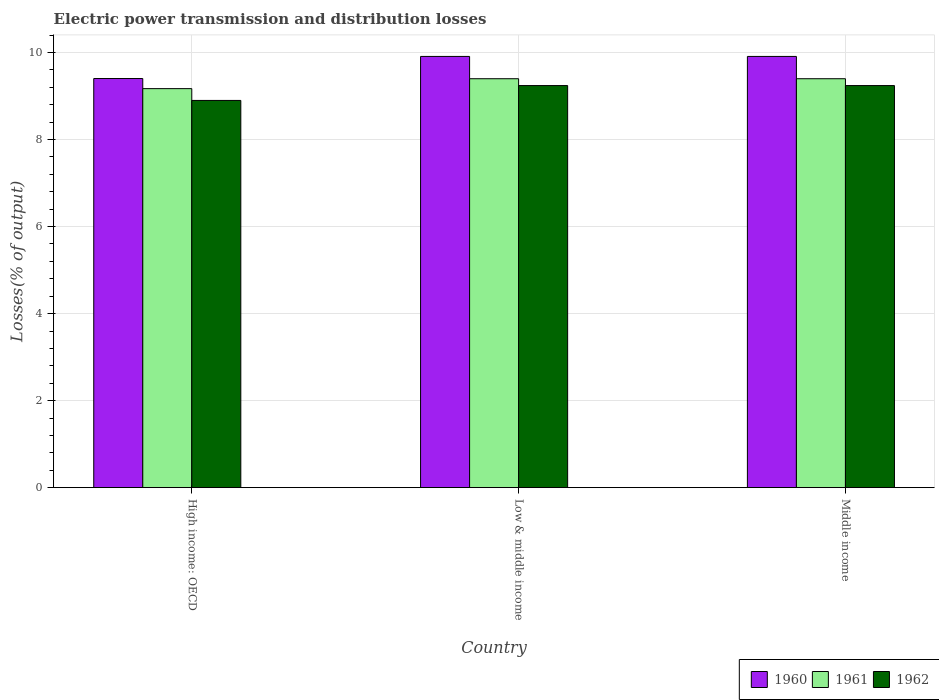How many different coloured bars are there?
Your response must be concise. 3. How many groups of bars are there?
Give a very brief answer. 3. Are the number of bars per tick equal to the number of legend labels?
Offer a terse response. Yes. Are the number of bars on each tick of the X-axis equal?
Offer a terse response. Yes. In how many cases, is the number of bars for a given country not equal to the number of legend labels?
Ensure brevity in your answer.  0. What is the electric power transmission and distribution losses in 1960 in Low & middle income?
Give a very brief answer. 9.91. Across all countries, what is the maximum electric power transmission and distribution losses in 1960?
Keep it short and to the point. 9.91. Across all countries, what is the minimum electric power transmission and distribution losses in 1961?
Make the answer very short. 9.17. In which country was the electric power transmission and distribution losses in 1960 minimum?
Your answer should be very brief. High income: OECD. What is the total electric power transmission and distribution losses in 1960 in the graph?
Provide a succinct answer. 29.23. What is the difference between the electric power transmission and distribution losses in 1961 in Low & middle income and that in Middle income?
Provide a short and direct response. 0. What is the difference between the electric power transmission and distribution losses in 1962 in Low & middle income and the electric power transmission and distribution losses in 1960 in Middle income?
Give a very brief answer. -0.67. What is the average electric power transmission and distribution losses in 1960 per country?
Keep it short and to the point. 9.74. What is the difference between the electric power transmission and distribution losses of/in 1962 and electric power transmission and distribution losses of/in 1960 in High income: OECD?
Your response must be concise. -0.5. What is the ratio of the electric power transmission and distribution losses in 1961 in High income: OECD to that in Low & middle income?
Your answer should be very brief. 0.98. Is the difference between the electric power transmission and distribution losses in 1962 in High income: OECD and Low & middle income greater than the difference between the electric power transmission and distribution losses in 1960 in High income: OECD and Low & middle income?
Provide a succinct answer. Yes. What is the difference between the highest and the second highest electric power transmission and distribution losses in 1960?
Give a very brief answer. 0.51. What is the difference between the highest and the lowest electric power transmission and distribution losses in 1962?
Your response must be concise. 0.34. What does the 1st bar from the left in High income: OECD represents?
Your answer should be compact. 1960. Is it the case that in every country, the sum of the electric power transmission and distribution losses in 1960 and electric power transmission and distribution losses in 1961 is greater than the electric power transmission and distribution losses in 1962?
Ensure brevity in your answer.  Yes. How many bars are there?
Your answer should be compact. 9. Are all the bars in the graph horizontal?
Make the answer very short. No. What is the difference between two consecutive major ticks on the Y-axis?
Your answer should be compact. 2. Does the graph contain grids?
Provide a succinct answer. Yes. Where does the legend appear in the graph?
Keep it short and to the point. Bottom right. How are the legend labels stacked?
Your response must be concise. Horizontal. What is the title of the graph?
Give a very brief answer. Electric power transmission and distribution losses. Does "1971" appear as one of the legend labels in the graph?
Give a very brief answer. No. What is the label or title of the Y-axis?
Make the answer very short. Losses(% of output). What is the Losses(% of output) in 1960 in High income: OECD?
Make the answer very short. 9.4. What is the Losses(% of output) of 1961 in High income: OECD?
Give a very brief answer. 9.17. What is the Losses(% of output) in 1962 in High income: OECD?
Ensure brevity in your answer.  8.9. What is the Losses(% of output) in 1960 in Low & middle income?
Make the answer very short. 9.91. What is the Losses(% of output) of 1961 in Low & middle income?
Ensure brevity in your answer.  9.4. What is the Losses(% of output) in 1962 in Low & middle income?
Provide a succinct answer. 9.24. What is the Losses(% of output) in 1960 in Middle income?
Provide a succinct answer. 9.91. What is the Losses(% of output) of 1961 in Middle income?
Provide a succinct answer. 9.4. What is the Losses(% of output) of 1962 in Middle income?
Offer a terse response. 9.24. Across all countries, what is the maximum Losses(% of output) in 1960?
Give a very brief answer. 9.91. Across all countries, what is the maximum Losses(% of output) in 1961?
Your answer should be very brief. 9.4. Across all countries, what is the maximum Losses(% of output) of 1962?
Give a very brief answer. 9.24. Across all countries, what is the minimum Losses(% of output) of 1960?
Your answer should be very brief. 9.4. Across all countries, what is the minimum Losses(% of output) in 1961?
Your response must be concise. 9.17. Across all countries, what is the minimum Losses(% of output) in 1962?
Provide a short and direct response. 8.9. What is the total Losses(% of output) in 1960 in the graph?
Your answer should be compact. 29.23. What is the total Losses(% of output) of 1961 in the graph?
Offer a very short reply. 27.97. What is the total Losses(% of output) of 1962 in the graph?
Provide a short and direct response. 27.38. What is the difference between the Losses(% of output) of 1960 in High income: OECD and that in Low & middle income?
Keep it short and to the point. -0.51. What is the difference between the Losses(% of output) of 1961 in High income: OECD and that in Low & middle income?
Offer a very short reply. -0.23. What is the difference between the Losses(% of output) of 1962 in High income: OECD and that in Low & middle income?
Your answer should be very brief. -0.34. What is the difference between the Losses(% of output) in 1960 in High income: OECD and that in Middle income?
Provide a short and direct response. -0.51. What is the difference between the Losses(% of output) of 1961 in High income: OECD and that in Middle income?
Provide a succinct answer. -0.23. What is the difference between the Losses(% of output) in 1962 in High income: OECD and that in Middle income?
Provide a short and direct response. -0.34. What is the difference between the Losses(% of output) in 1960 in Low & middle income and that in Middle income?
Offer a terse response. 0. What is the difference between the Losses(% of output) of 1961 in Low & middle income and that in Middle income?
Provide a succinct answer. 0. What is the difference between the Losses(% of output) of 1960 in High income: OECD and the Losses(% of output) of 1961 in Low & middle income?
Ensure brevity in your answer.  0. What is the difference between the Losses(% of output) in 1960 in High income: OECD and the Losses(% of output) in 1962 in Low & middle income?
Make the answer very short. 0.16. What is the difference between the Losses(% of output) of 1961 in High income: OECD and the Losses(% of output) of 1962 in Low & middle income?
Your answer should be compact. -0.07. What is the difference between the Losses(% of output) in 1960 in High income: OECD and the Losses(% of output) in 1961 in Middle income?
Provide a short and direct response. 0. What is the difference between the Losses(% of output) in 1960 in High income: OECD and the Losses(% of output) in 1962 in Middle income?
Ensure brevity in your answer.  0.16. What is the difference between the Losses(% of output) of 1961 in High income: OECD and the Losses(% of output) of 1962 in Middle income?
Keep it short and to the point. -0.07. What is the difference between the Losses(% of output) in 1960 in Low & middle income and the Losses(% of output) in 1961 in Middle income?
Provide a succinct answer. 0.51. What is the difference between the Losses(% of output) in 1960 in Low & middle income and the Losses(% of output) in 1962 in Middle income?
Give a very brief answer. 0.67. What is the difference between the Losses(% of output) of 1961 in Low & middle income and the Losses(% of output) of 1962 in Middle income?
Your answer should be very brief. 0.16. What is the average Losses(% of output) of 1960 per country?
Make the answer very short. 9.74. What is the average Losses(% of output) of 1961 per country?
Your response must be concise. 9.32. What is the average Losses(% of output) of 1962 per country?
Offer a very short reply. 9.13. What is the difference between the Losses(% of output) in 1960 and Losses(% of output) in 1961 in High income: OECD?
Keep it short and to the point. 0.23. What is the difference between the Losses(% of output) of 1960 and Losses(% of output) of 1962 in High income: OECD?
Your response must be concise. 0.5. What is the difference between the Losses(% of output) of 1961 and Losses(% of output) of 1962 in High income: OECD?
Your answer should be very brief. 0.27. What is the difference between the Losses(% of output) in 1960 and Losses(% of output) in 1961 in Low & middle income?
Offer a very short reply. 0.51. What is the difference between the Losses(% of output) in 1960 and Losses(% of output) in 1962 in Low & middle income?
Provide a short and direct response. 0.67. What is the difference between the Losses(% of output) in 1961 and Losses(% of output) in 1962 in Low & middle income?
Keep it short and to the point. 0.16. What is the difference between the Losses(% of output) of 1960 and Losses(% of output) of 1961 in Middle income?
Offer a terse response. 0.51. What is the difference between the Losses(% of output) of 1960 and Losses(% of output) of 1962 in Middle income?
Make the answer very short. 0.67. What is the difference between the Losses(% of output) in 1961 and Losses(% of output) in 1962 in Middle income?
Ensure brevity in your answer.  0.16. What is the ratio of the Losses(% of output) of 1960 in High income: OECD to that in Low & middle income?
Provide a short and direct response. 0.95. What is the ratio of the Losses(% of output) in 1961 in High income: OECD to that in Low & middle income?
Offer a very short reply. 0.98. What is the ratio of the Losses(% of output) in 1960 in High income: OECD to that in Middle income?
Your response must be concise. 0.95. What is the ratio of the Losses(% of output) in 1961 in High income: OECD to that in Middle income?
Keep it short and to the point. 0.98. What is the ratio of the Losses(% of output) of 1962 in High income: OECD to that in Middle income?
Offer a very short reply. 0.96. What is the ratio of the Losses(% of output) of 1961 in Low & middle income to that in Middle income?
Provide a short and direct response. 1. What is the difference between the highest and the second highest Losses(% of output) of 1961?
Provide a short and direct response. 0. What is the difference between the highest and the lowest Losses(% of output) in 1960?
Ensure brevity in your answer.  0.51. What is the difference between the highest and the lowest Losses(% of output) of 1961?
Offer a terse response. 0.23. What is the difference between the highest and the lowest Losses(% of output) in 1962?
Ensure brevity in your answer.  0.34. 